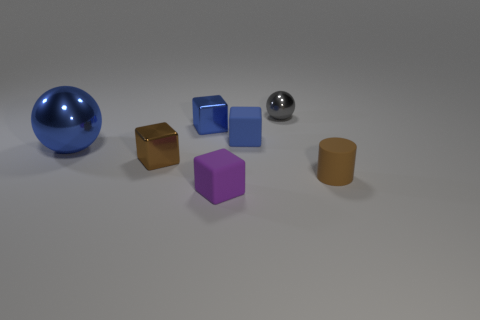There is a thing that is the same color as the matte cylinder; what size is it? The sphere that shares the matte cylinder's color is large in comparison to other objects in the scene. 